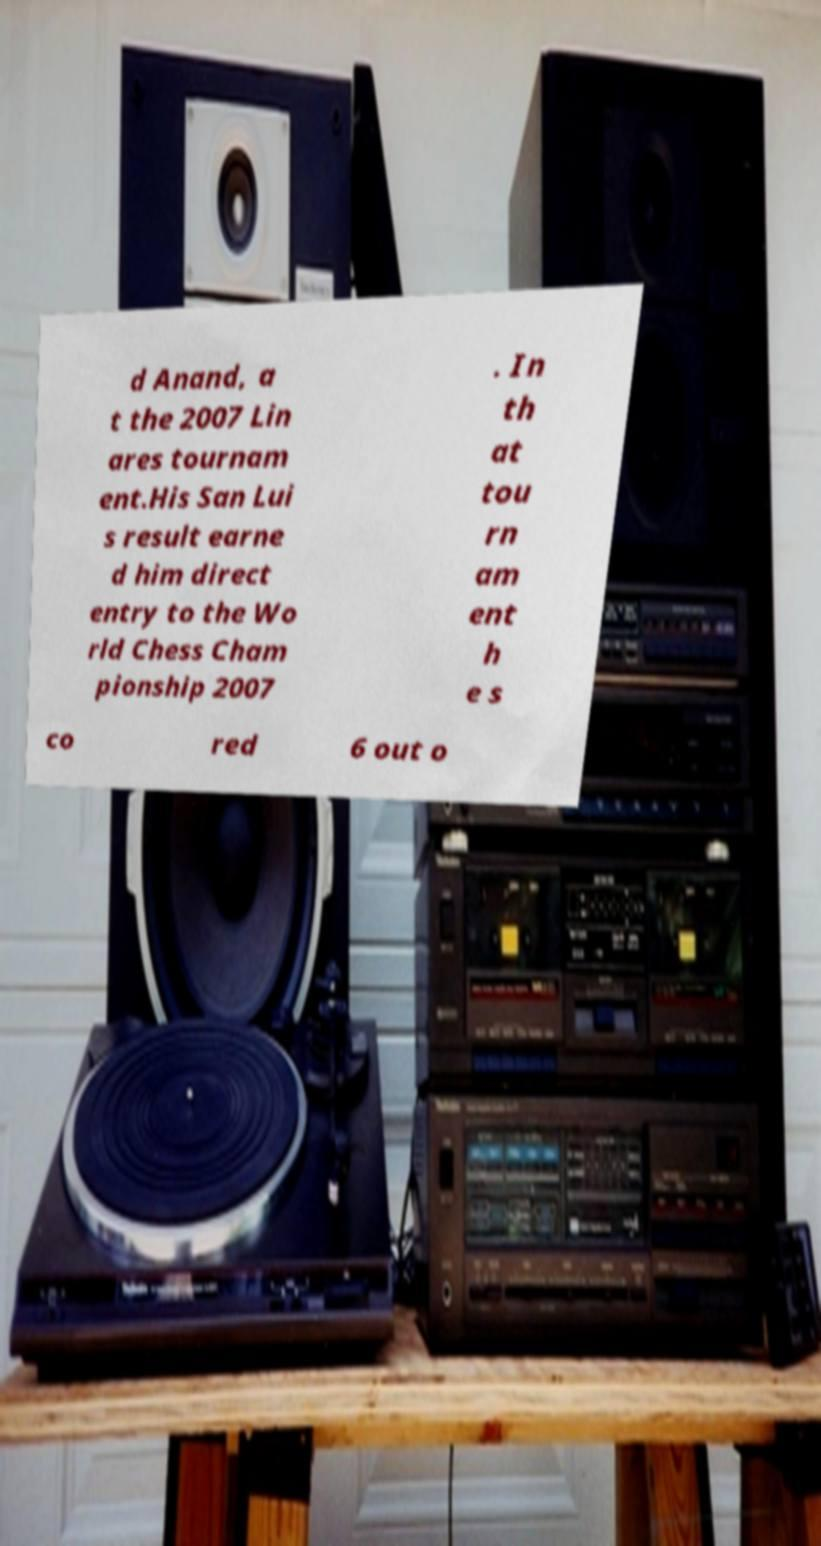Can you accurately transcribe the text from the provided image for me? d Anand, a t the 2007 Lin ares tournam ent.His San Lui s result earne d him direct entry to the Wo rld Chess Cham pionship 2007 . In th at tou rn am ent h e s co red 6 out o 